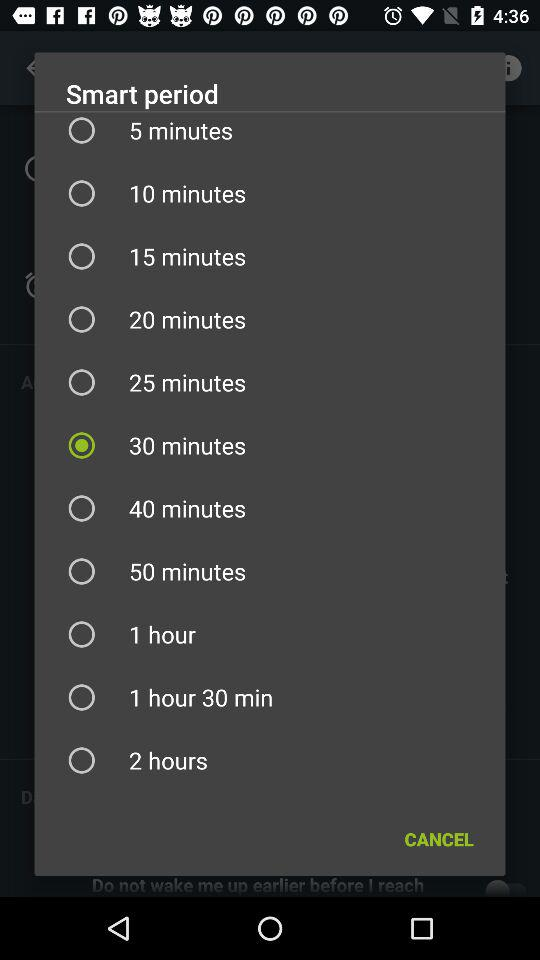How many minutes are there in the longest period?
Answer the question using a single word or phrase. 120 